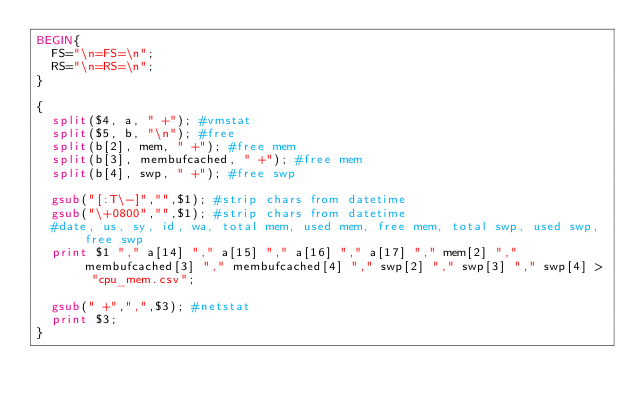Convert code to text. <code><loc_0><loc_0><loc_500><loc_500><_Awk_>BEGIN{
	FS="\n=FS=\n";
	RS="\n=RS=\n";
}

{
	split($4, a, " +"); #vmstat
	split($5, b, "\n"); #free
	split(b[2], mem, " +"); #free mem
	split(b[3], membufcached, " +"); #free mem
	split(b[4], swp, " +"); #free swp

	gsub("[:T\-]","",$1); #strip chars from datetime
	gsub("\+0800","",$1); #strip chars from datetime
	#date, us, sy, id, wa, total mem, used mem, free mem, total swp, used swp, free swp
	print $1 "," a[14] "," a[15] "," a[16] "," a[17] "," mem[2] "," membufcached[3] "," membufcached[4] "," swp[2] "," swp[3] "," swp[4] > "cpu_mem.csv";

	gsub(" +",",",$3); #netstat
	print $3;
}
</code> 